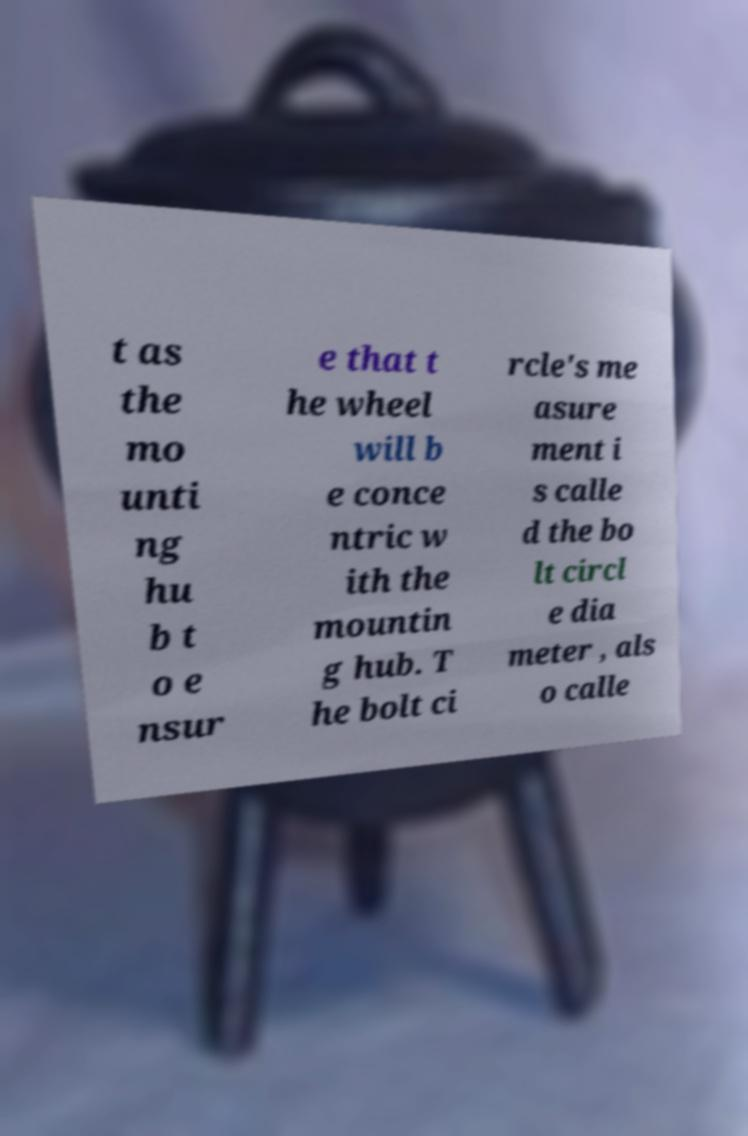There's text embedded in this image that I need extracted. Can you transcribe it verbatim? t as the mo unti ng hu b t o e nsur e that t he wheel will b e conce ntric w ith the mountin g hub. T he bolt ci rcle's me asure ment i s calle d the bo lt circl e dia meter , als o calle 